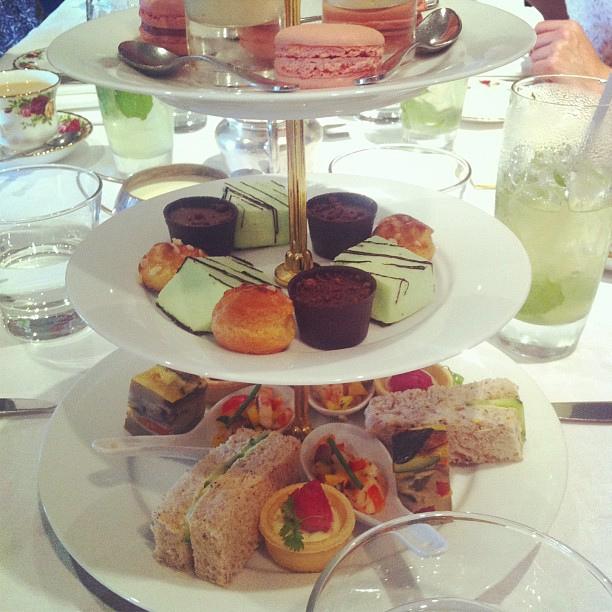How many plates are in this photo?
Quick response, please. 3. Where is the teacup?
Concise answer only. Table. Where is the strawberry?
Give a very brief answer. On tart. 